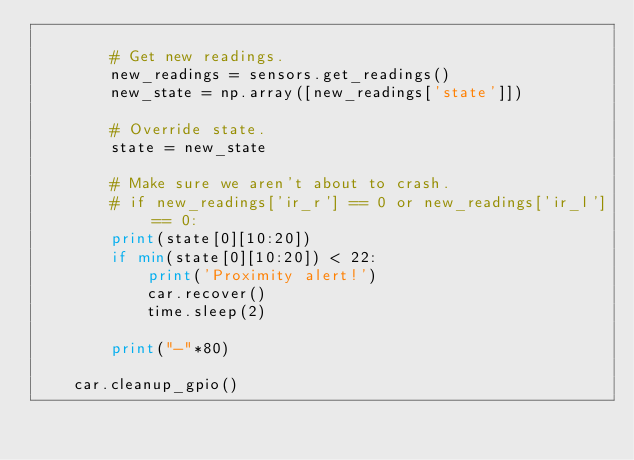<code> <loc_0><loc_0><loc_500><loc_500><_Python_>
        # Get new readings.
        new_readings = sensors.get_readings()
        new_state = np.array([new_readings['state']])

        # Override state.
        state = new_state

        # Make sure we aren't about to crash.
        # if new_readings['ir_r'] == 0 or new_readings['ir_l'] == 0:
        print(state[0][10:20])
        if min(state[0][10:20]) < 22:
            print('Proximity alert!')
            car.recover()
            time.sleep(2)

        print("-"*80)

    car.cleanup_gpio()
</code> 